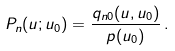Convert formula to latex. <formula><loc_0><loc_0><loc_500><loc_500>P _ { n } ( u ; u _ { 0 } ) = \frac { q _ { n 0 } ( u , u _ { 0 } ) } { p ( u _ { 0 } ) } \, .</formula> 